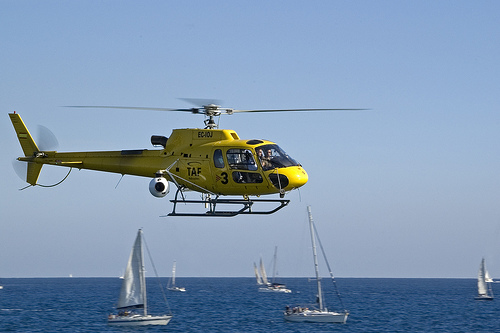<image>
Is the sail boat next to the helicopter? No. The sail boat is not positioned next to the helicopter. They are located in different areas of the scene. Where is the chopper in relation to the boat? Is it above the boat? Yes. The chopper is positioned above the boat in the vertical space, higher up in the scene. 